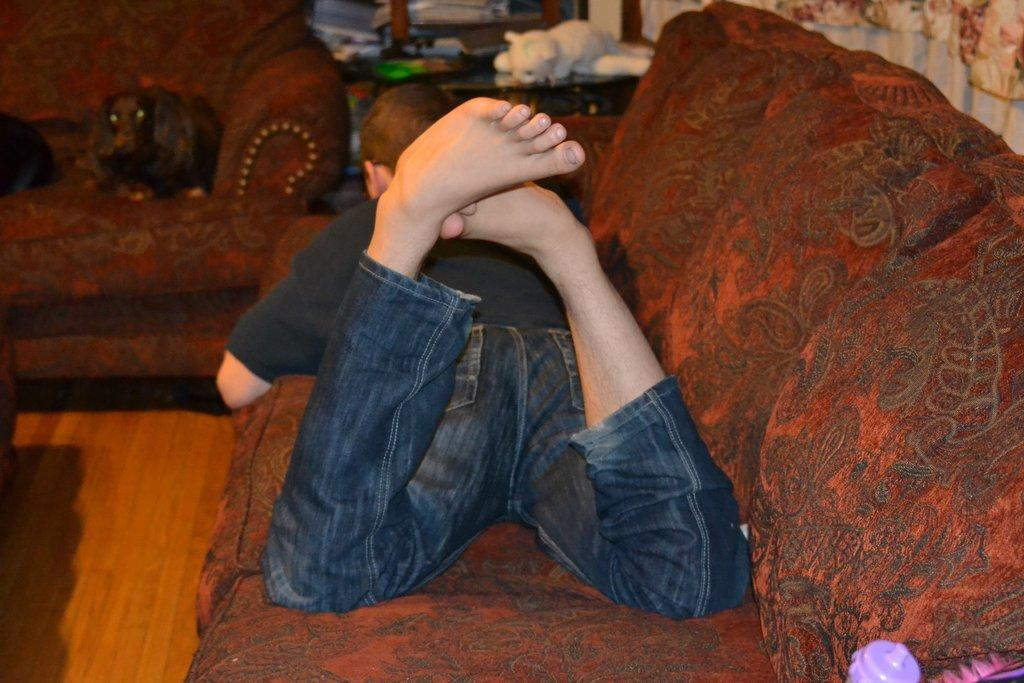What is the person in the image doing? The person is laying on the couch. What color is the couch? The couch is maroon in color. What is the person wearing on their upper body? The person is wearing a black shirt. What is the person wearing on their lower body? The person is wearing blue pants. What can be seen on a table in the background? There are toys on a table in the background. What type of card is the person holding in the image? There is no card present in the image; the person is laying on the couch and wearing clothes. 